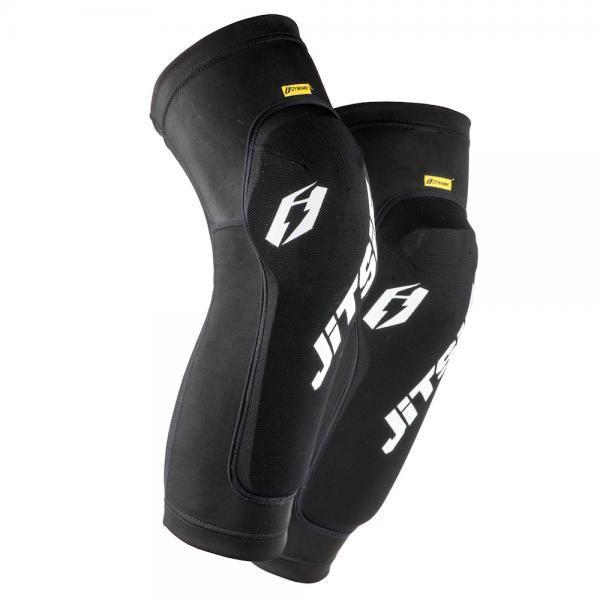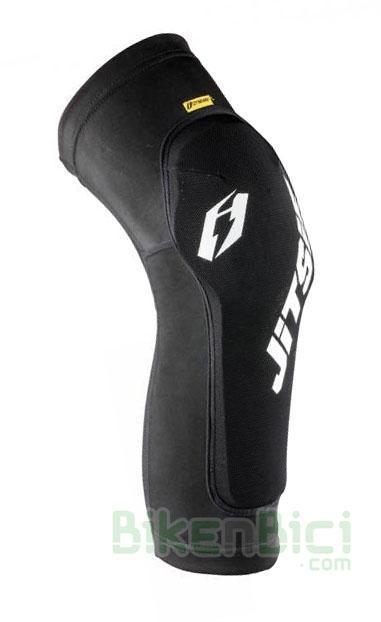The first image is the image on the left, the second image is the image on the right. Evaluate the accuracy of this statement regarding the images: "The pads are facing left in both images.". Is it true? Answer yes or no. No. 